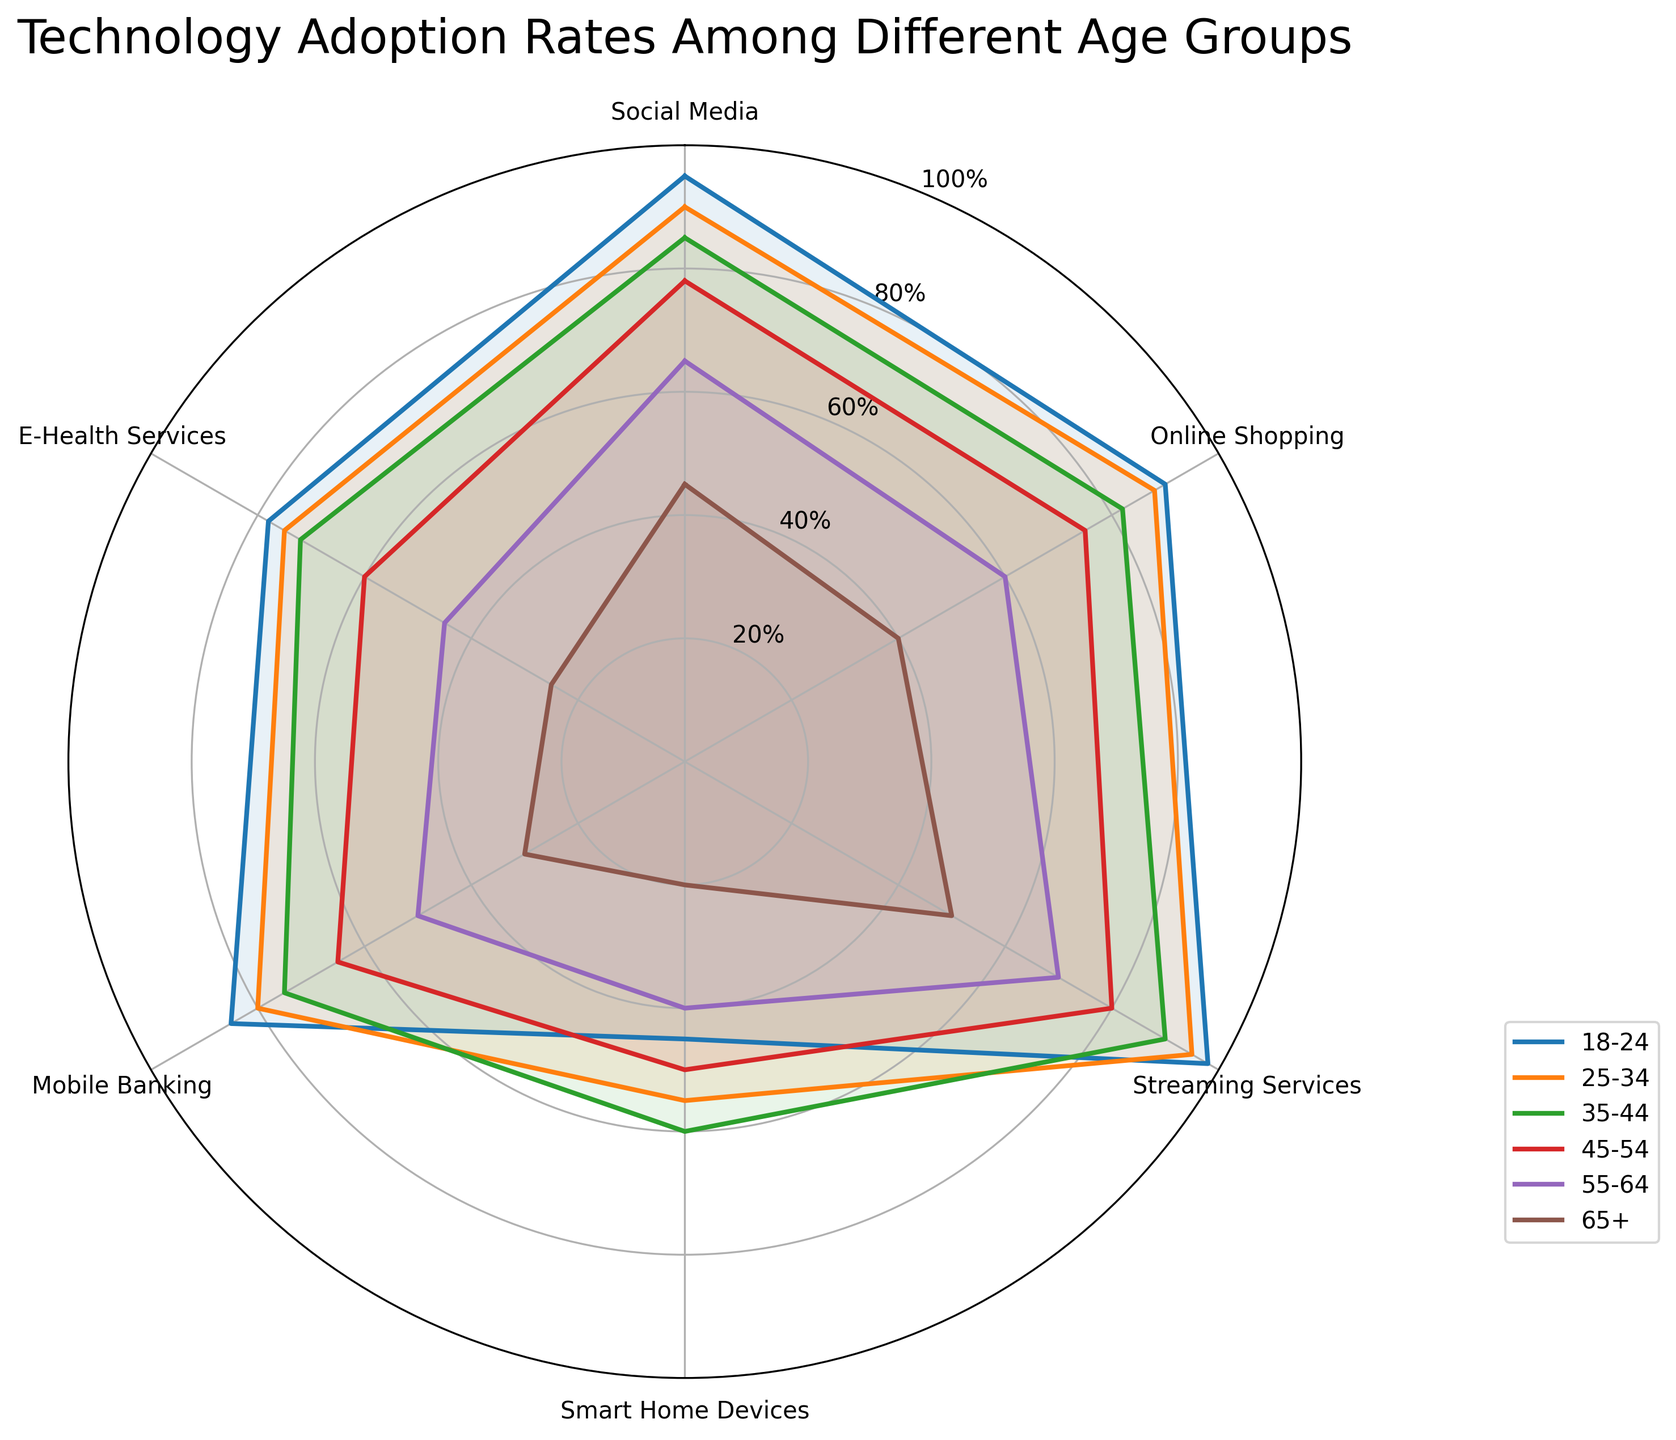What is the title of the radar chart? The title is displayed at the top of the radar chart, usually in a larger and bold font. Look for the text above the data visualizations.
Answer: Technology Adoption Rates Among Different Age Groups What age group has the highest adoption rate for social media? Look at the data points for social media, represented on the radar chart. The data points will be at the highest value for the age group with the highest adoption rate.
Answer: 18-24 Which technology shows the most significant decrease in adoption rates as age increases? Compare the lines for each technology across different age groups. Identify the one with the steepest slope or the greatest vertical difference between the youngest and oldest age groups.
Answer: Social Media Which age group has the lowest adoption rate for smart home devices? Data points for each age group will indicate different values for smart home devices. The age group associated with the smallest data point is the one with the lowest adoption rate.
Answer: 65+ How does the adoption rate of e-health services compare between the 35-44 and 55-64 age groups? Identify and compare the data points for e-health services for both age groups. The 35-44 data point value and the 55-64 data point value can be directly compared.
Answer: 35-44 group is higher What is the average adoption rate of mobile banking for all age groups? Find and sum the adoption rates for mobile banking across all age groups: (85+80+75+65+50+30). Divide the sum by the number of age groups, which is 6.
Answer: (85+80+75+65+50+30)/6 = 64.17 Which age group has the closest adoption rates for online shopping and streaming services? Check the radar chart for how close the data points for online shopping and streaming services are for each age group. The age group with the least difference between these two technologies has the closest adoption rates.
Answer: 18-24 For the 45-54 age group, what is the range of adoption rates across all technologies? Identify the minimum and maximum values for adoption rates across all technologies for the 45-54 age group. Subtract the minimum value from the maximum value to find the range.
Answer: 80-50 = 30 Is there any age group that has higher mobile banking adoption than social media adoption? For each age group, compare the data points for mobile banking and social media. An age group where the mobile banking data point is higher than the social media data point is what we are looking for.
Answer: No Which two technologies have the smallest gap in adoption rates for the 25-34 age group? For the 25-34 age group, evaluate the adoption rates for each pair of technologies and calculate the gaps. The smallest numerical difference will be the answer.
Answer: Online Shopping and Mobile Banking (88-80=8) 